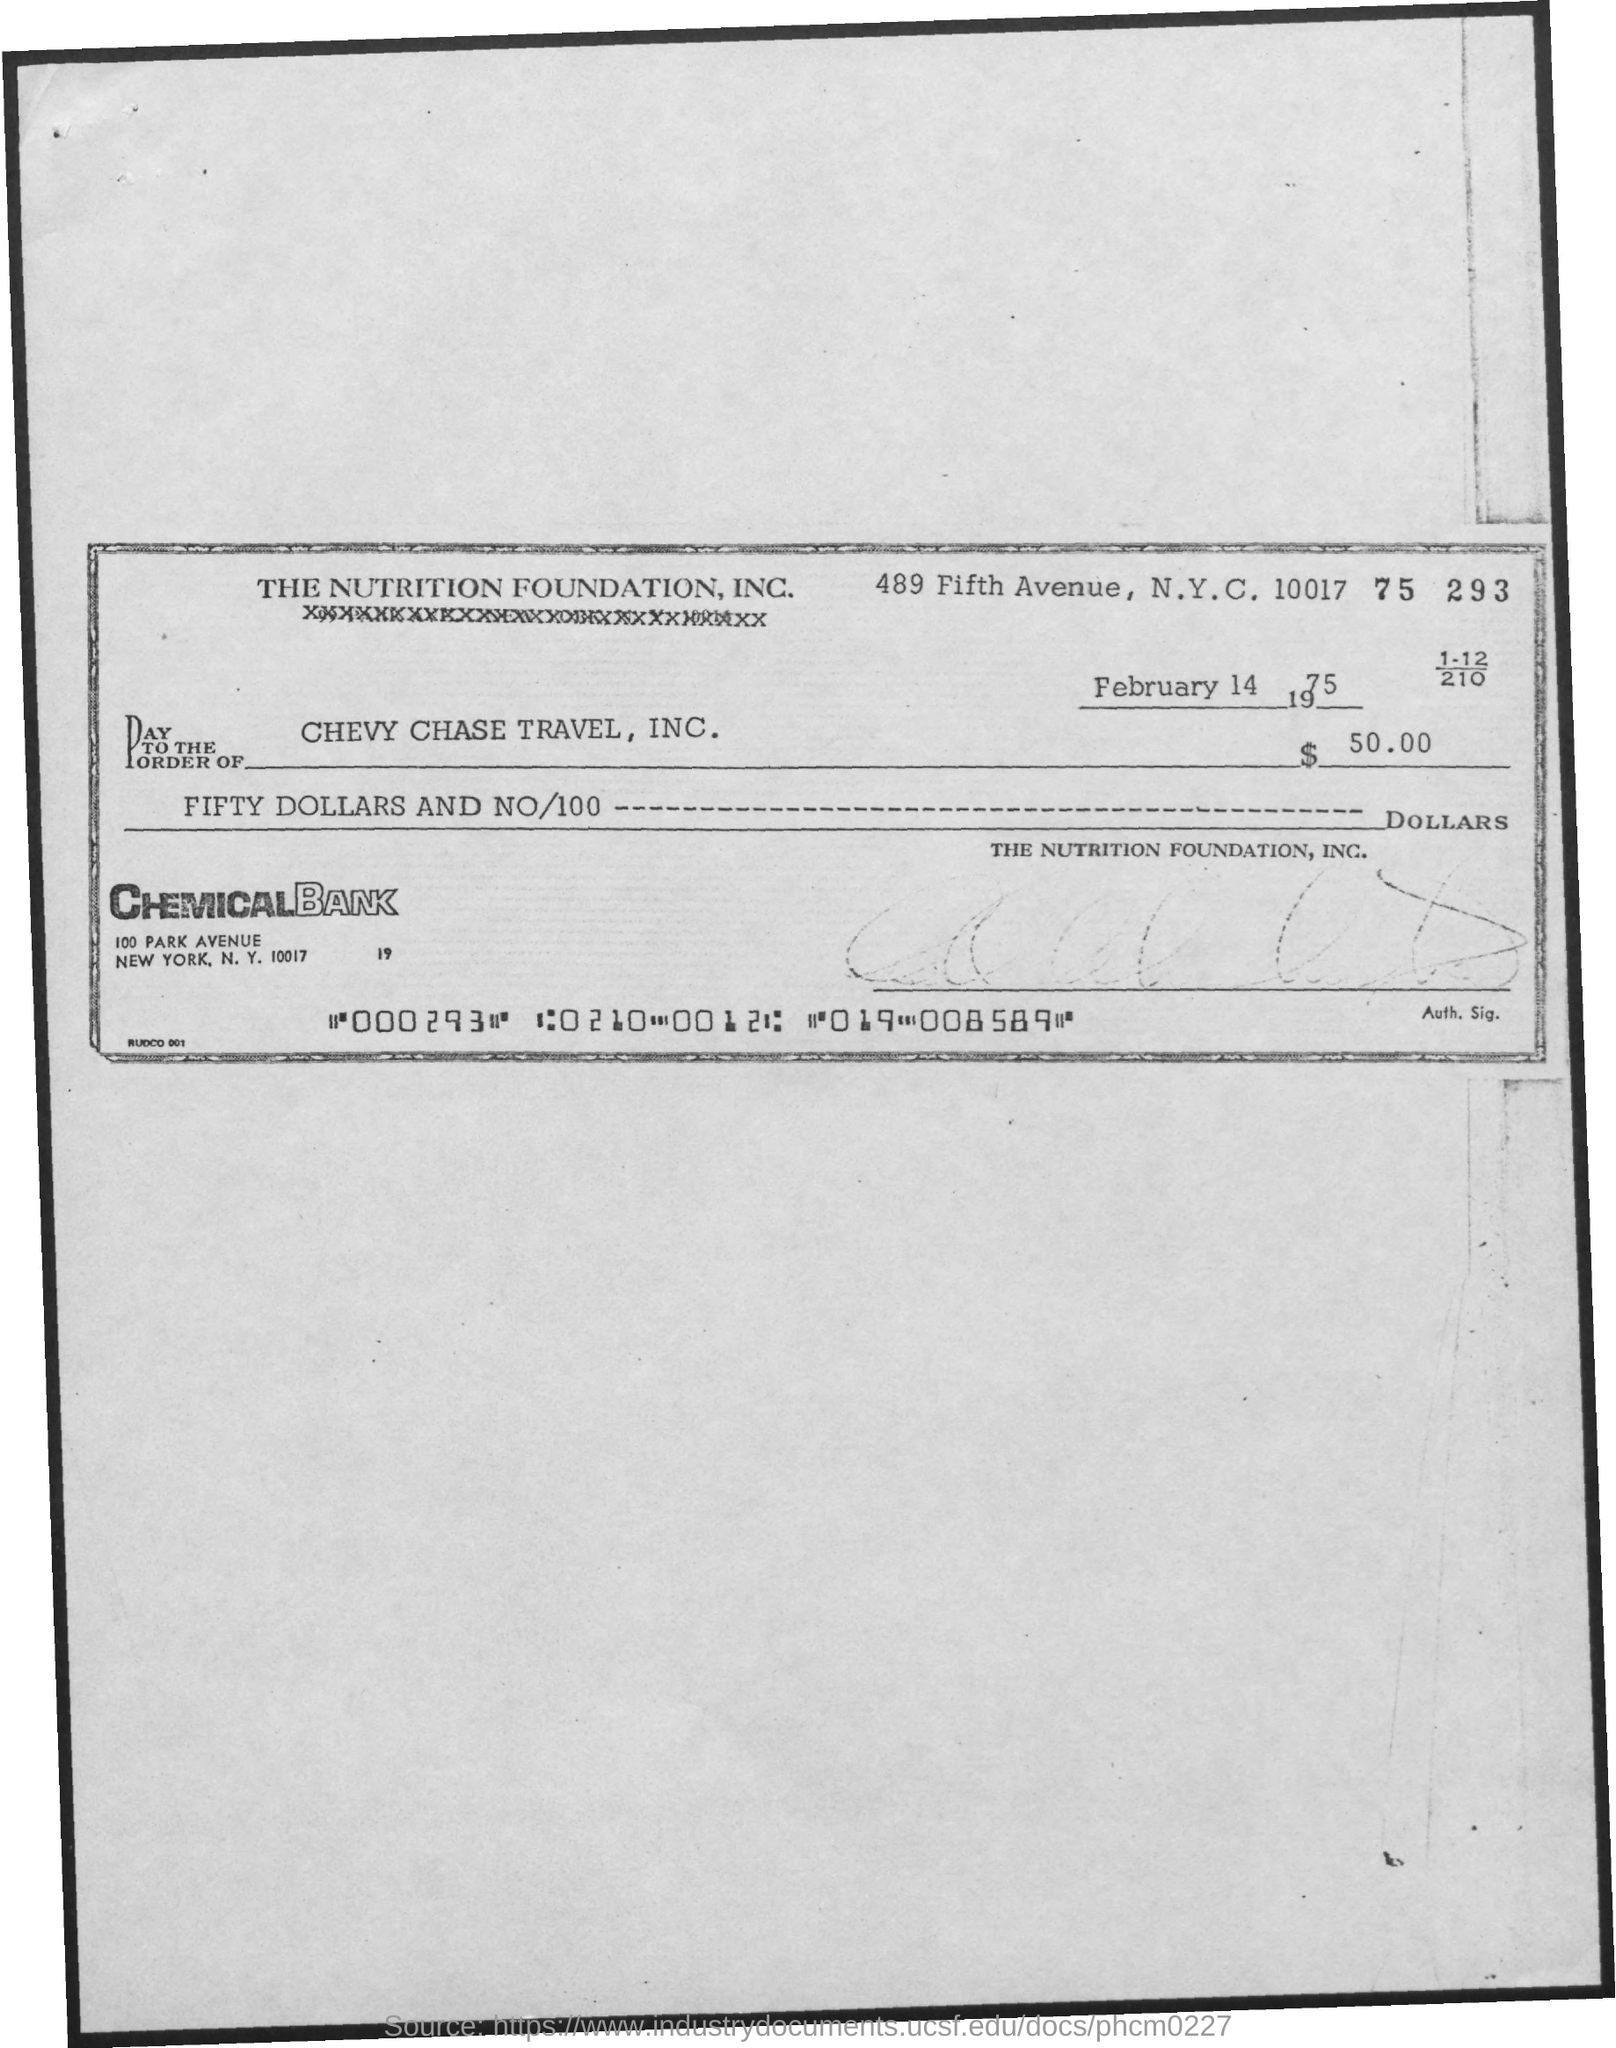What is the name of the bank mentioned in the document?
Provide a short and direct response. Chemical Bank. 